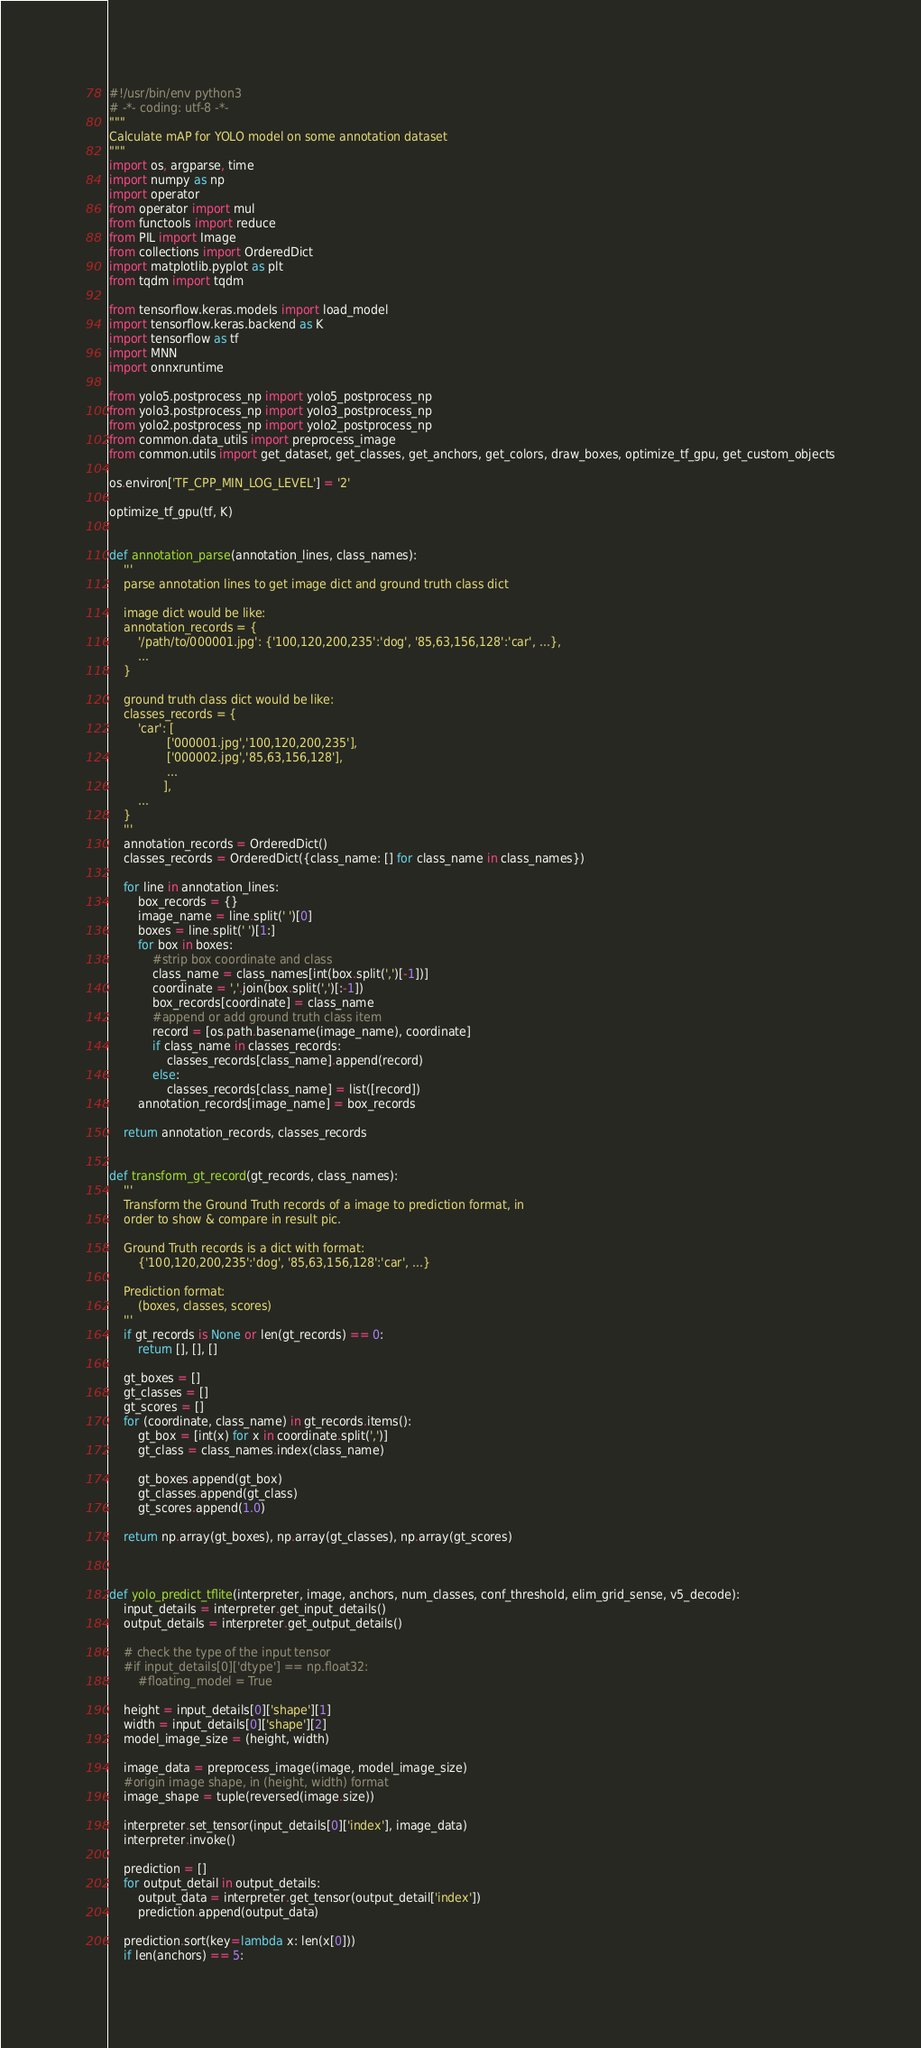Convert code to text. <code><loc_0><loc_0><loc_500><loc_500><_Python_>#!/usr/bin/env python3
# -*- coding: utf-8 -*-
"""
Calculate mAP for YOLO model on some annotation dataset
"""
import os, argparse, time
import numpy as np
import operator
from operator import mul
from functools import reduce
from PIL import Image
from collections import OrderedDict
import matplotlib.pyplot as plt
from tqdm import tqdm

from tensorflow.keras.models import load_model
import tensorflow.keras.backend as K
import tensorflow as tf
import MNN
import onnxruntime

from yolo5.postprocess_np import yolo5_postprocess_np
from yolo3.postprocess_np import yolo3_postprocess_np
from yolo2.postprocess_np import yolo2_postprocess_np
from common.data_utils import preprocess_image
from common.utils import get_dataset, get_classes, get_anchors, get_colors, draw_boxes, optimize_tf_gpu, get_custom_objects

os.environ['TF_CPP_MIN_LOG_LEVEL'] = '2'

optimize_tf_gpu(tf, K)


def annotation_parse(annotation_lines, class_names):
    '''
    parse annotation lines to get image dict and ground truth class dict

    image dict would be like:
    annotation_records = {
        '/path/to/000001.jpg': {'100,120,200,235':'dog', '85,63,156,128':'car', ...},
        ...
    }

    ground truth class dict would be like:
    classes_records = {
        'car': [
                ['000001.jpg','100,120,200,235'],
                ['000002.jpg','85,63,156,128'],
                ...
               ],
        ...
    }
    '''
    annotation_records = OrderedDict()
    classes_records = OrderedDict({class_name: [] for class_name in class_names})

    for line in annotation_lines:
        box_records = {}
        image_name = line.split(' ')[0]
        boxes = line.split(' ')[1:]
        for box in boxes:
            #strip box coordinate and class
            class_name = class_names[int(box.split(',')[-1])]
            coordinate = ','.join(box.split(',')[:-1])
            box_records[coordinate] = class_name
            #append or add ground truth class item
            record = [os.path.basename(image_name), coordinate]
            if class_name in classes_records:
                classes_records[class_name].append(record)
            else:
                classes_records[class_name] = list([record])
        annotation_records[image_name] = box_records

    return annotation_records, classes_records


def transform_gt_record(gt_records, class_names):
    '''
    Transform the Ground Truth records of a image to prediction format, in
    order to show & compare in result pic.

    Ground Truth records is a dict with format:
        {'100,120,200,235':'dog', '85,63,156,128':'car', ...}

    Prediction format:
        (boxes, classes, scores)
    '''
    if gt_records is None or len(gt_records) == 0:
        return [], [], []

    gt_boxes = []
    gt_classes = []
    gt_scores = []
    for (coordinate, class_name) in gt_records.items():
        gt_box = [int(x) for x in coordinate.split(',')]
        gt_class = class_names.index(class_name)

        gt_boxes.append(gt_box)
        gt_classes.append(gt_class)
        gt_scores.append(1.0)

    return np.array(gt_boxes), np.array(gt_classes), np.array(gt_scores)



def yolo_predict_tflite(interpreter, image, anchors, num_classes, conf_threshold, elim_grid_sense, v5_decode):
    input_details = interpreter.get_input_details()
    output_details = interpreter.get_output_details()

    # check the type of the input tensor
    #if input_details[0]['dtype'] == np.float32:
        #floating_model = True

    height = input_details[0]['shape'][1]
    width = input_details[0]['shape'][2]
    model_image_size = (height, width)

    image_data = preprocess_image(image, model_image_size)
    #origin image shape, in (height, width) format
    image_shape = tuple(reversed(image.size))

    interpreter.set_tensor(input_details[0]['index'], image_data)
    interpreter.invoke()

    prediction = []
    for output_detail in output_details:
        output_data = interpreter.get_tensor(output_detail['index'])
        prediction.append(output_data)

    prediction.sort(key=lambda x: len(x[0]))
    if len(anchors) == 5:</code> 